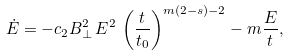<formula> <loc_0><loc_0><loc_500><loc_500>\dot { E } = - c _ { 2 } B _ { \perp } ^ { 2 } \, E ^ { 2 } \, \left ( \frac { t } { t _ { 0 } } \right ) ^ { m ( 2 - s ) - 2 } - m \frac { E } { t } ,</formula> 